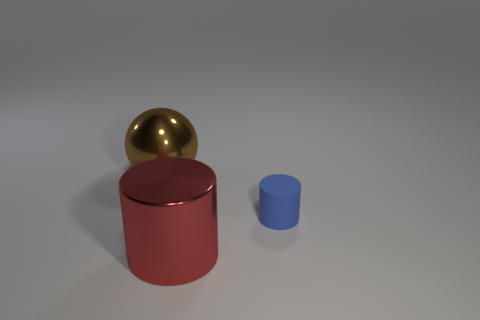Add 3 big objects. How many objects exist? 6 Subtract all spheres. How many objects are left? 2 Subtract 1 spheres. How many spheres are left? 0 Subtract all tiny gray rubber balls. Subtract all big brown metal things. How many objects are left? 2 Add 1 big objects. How many big objects are left? 3 Add 3 shiny blocks. How many shiny blocks exist? 3 Subtract 1 brown balls. How many objects are left? 2 Subtract all green cylinders. Subtract all brown blocks. How many cylinders are left? 2 